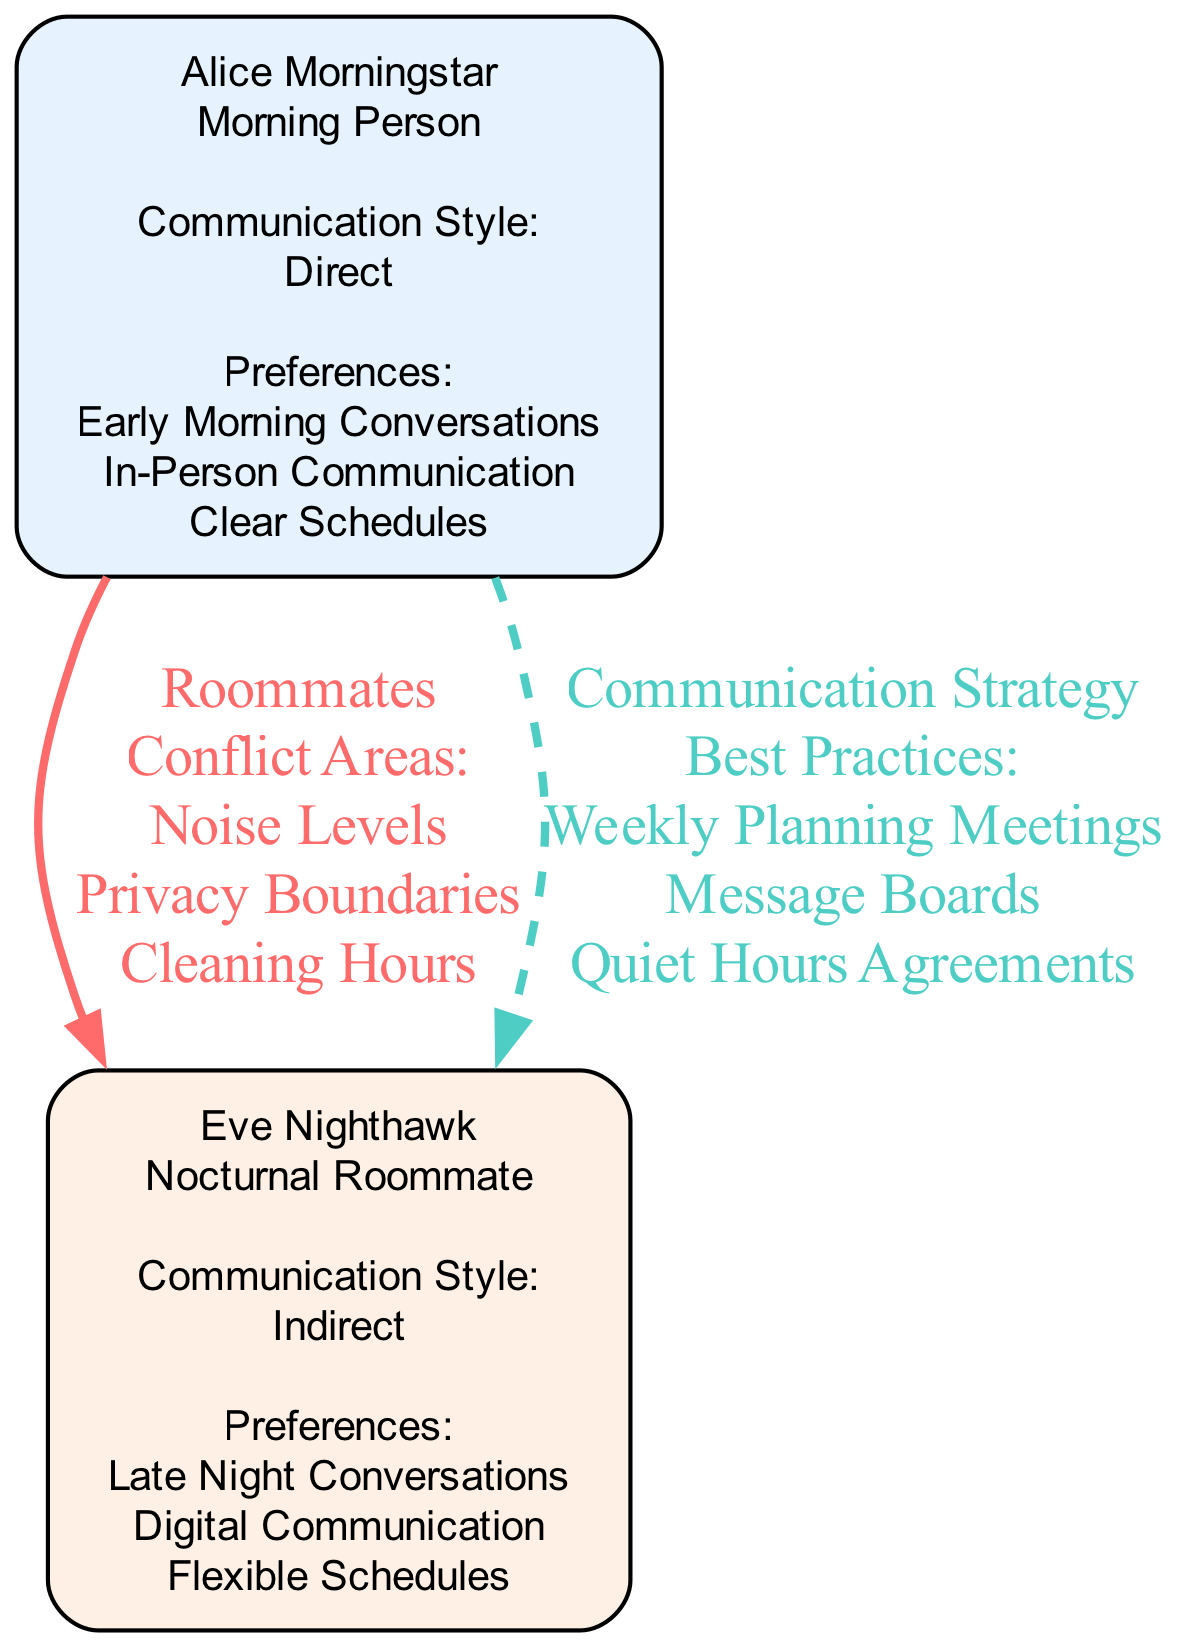What is Alice Morningstar’s communication style? The diagram shows that Alice Morningstar has a "Direct" communication style. This information is presented within her individual node, where her preferences and style are listed.
Answer: Direct How many conflict areas are listed between Alice and Eve? By reviewing the relationship edge from Alice to Eve labeled "Roommates," we find that it includes three conflict areas: Noise Levels, Privacy Boundaries, and Cleaning Hours. Therefore, the total count is three.
Answer: 3 What is Eve Nighthawk’s role in the shared living environment? Looking at Eve Nighthawk’s individual node, her role is identified as a "Nocturnal Roommate." This is explicitly stated in her label, which describes her role and communication aspects.
Answer: Nocturnal Roommate What is one best practice for the communication strategy between Alice and Eve? The edge labeled "Communication Strategy" details best practices that include "Weekly Planning Meetings." This is identified as one of the recommended strategies for improving their communication.
Answer: Weekly Planning Meetings What are the noise levels categorized under? The conflict area related to noise levels is categorized under the "Roommates" relationship between Alice and Eve. This is visible within the edge connecting them, where multiple conflict areas are listed together.
Answer: Roommates How does Alice prefer to communicate? Based on Alice's individual node, she prefers "In-Person Communication." This preference is explicitly mentioned in the list of her preferences, detailing how she likes to converse with her roommate.
Answer: In-Person Communication What communication style does Eve Nighthawk prefer? Analyzing Eve's node, it is shown that she has an "Indirect" communication style. This is clearly outlined in her node among the other attributes.
Answer: Indirect What are Alice's preferences for communication times? Within Alice's preferences section, it states that she prefers "Early Morning Conversations." This indicates her preferred times for engaging in communication with her roommate.
Answer: Early Morning Conversations What type of relationship do Alice and Eve have? The relationship type connecting Alice and Eve is labeled as "Roommates." This is the first relationship listed in the diagram, making it a straightforward identification.
Answer: Roommates 